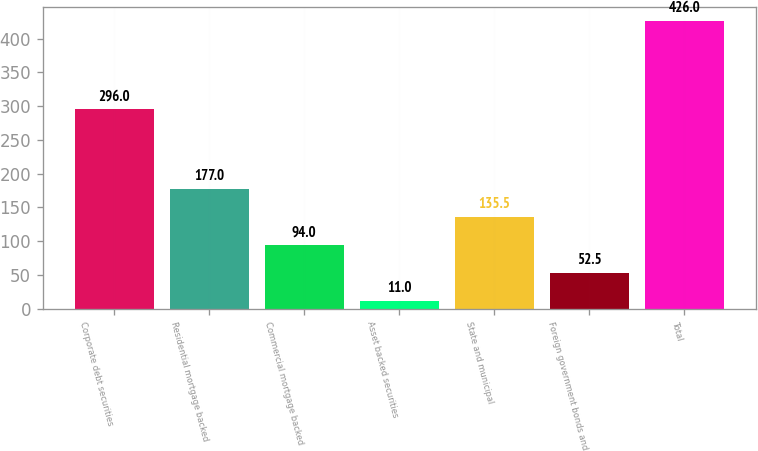<chart> <loc_0><loc_0><loc_500><loc_500><bar_chart><fcel>Corporate debt securities<fcel>Residential mortgage backed<fcel>Commercial mortgage backed<fcel>Asset backed securities<fcel>State and municipal<fcel>Foreign government bonds and<fcel>Total<nl><fcel>296<fcel>177<fcel>94<fcel>11<fcel>135.5<fcel>52.5<fcel>426<nl></chart> 